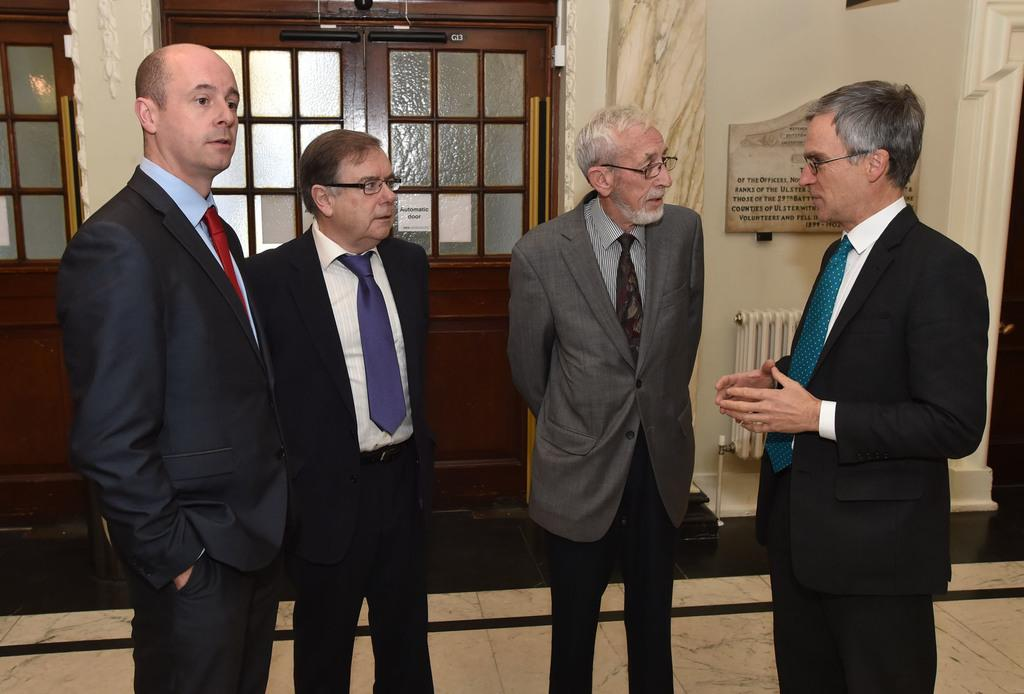How many people are in the image? There is a group of people standing in the image. Where are the people standing? The people are standing on the floor. What can be seen on the right side of the image? There is a board with text on the right side of the image. What architectural features can be seen in the background of the image? There are doors visible in the background of the image. What type of beans are being served on the table in the image? There is no table or beans present in the image. How many tomatoes are on the floor in the image? There are no tomatoes present in the image. 